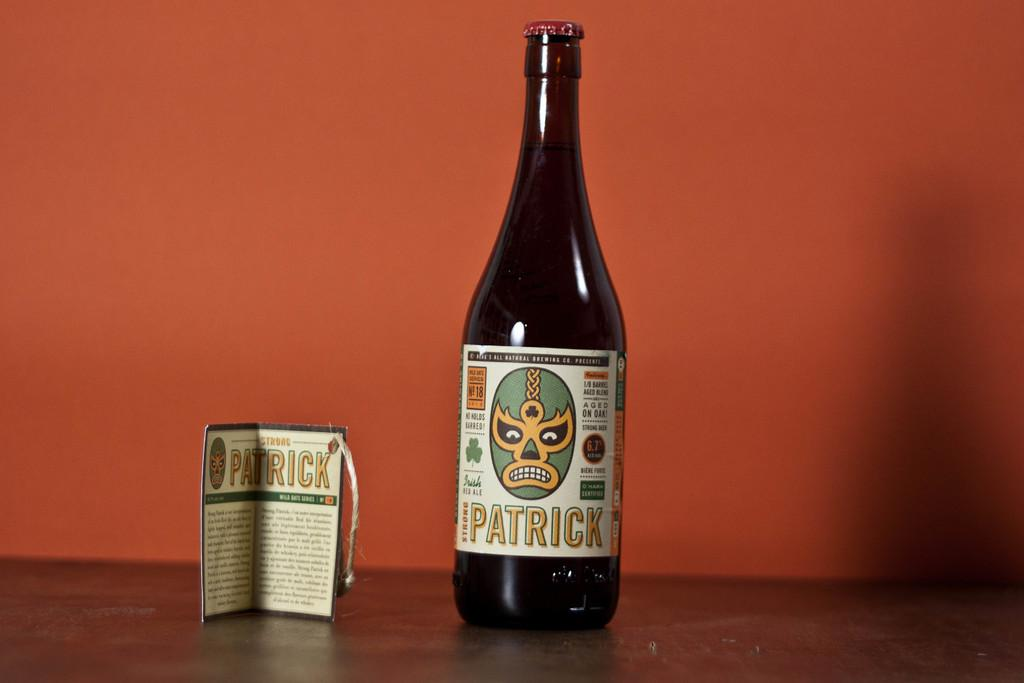<image>
Provide a brief description of the given image. A bottle of Strong Patrick next to it's label. 